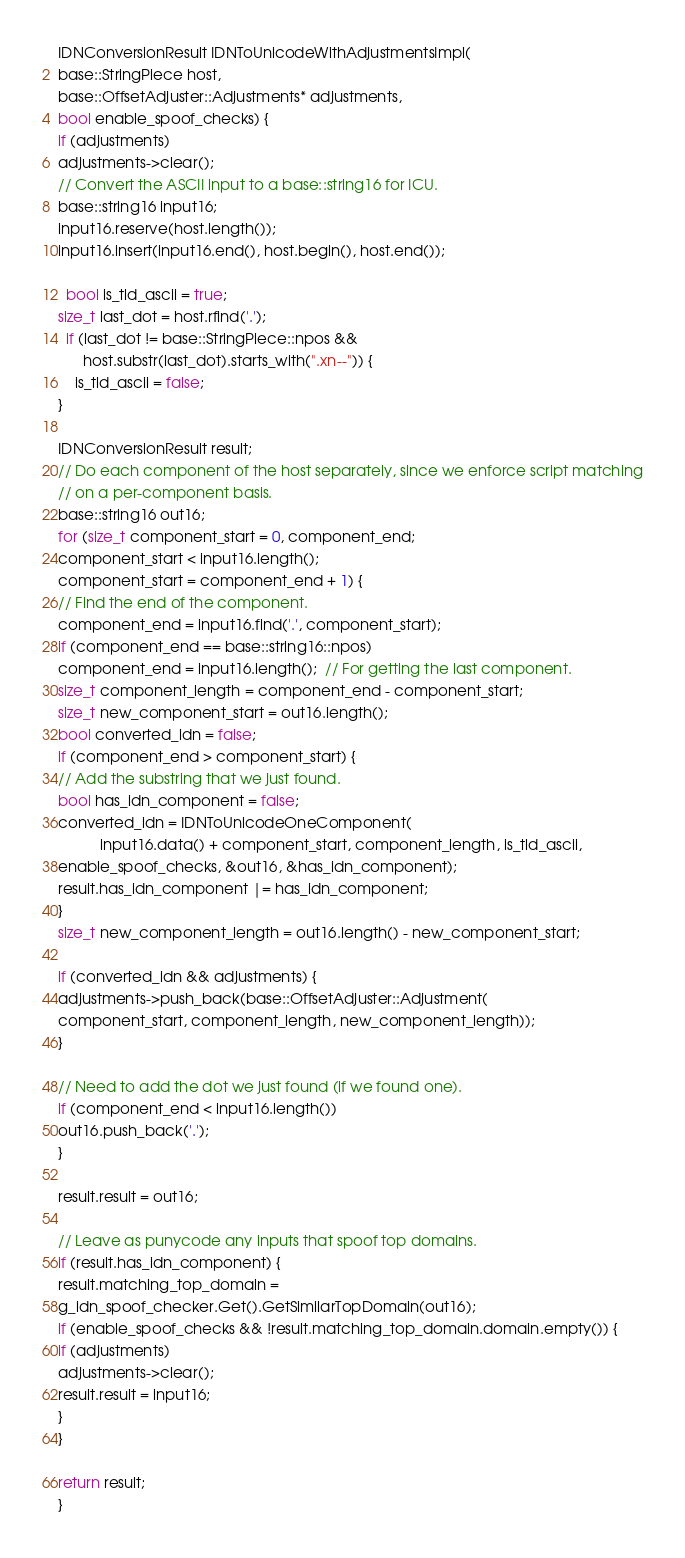<code> <loc_0><loc_0><loc_500><loc_500><_C++_>IDNConversionResult IDNToUnicodeWithAdjustmentsImpl(
base::StringPiece host,
base::OffsetAdjuster::Adjustments* adjustments,
bool enable_spoof_checks) {
if (adjustments)
adjustments->clear();
// Convert the ASCII input to a base::string16 for ICU.
base::string16 input16;
input16.reserve(host.length());
input16.insert(input16.end(), host.begin(), host.end());

  bool is_tld_ascii = true;
size_t last_dot = host.rfind('.');
  if (last_dot != base::StringPiece::npos &&
      host.substr(last_dot).starts_with(".xn--")) {
    is_tld_ascii = false;
}

IDNConversionResult result;
// Do each component of the host separately, since we enforce script matching
// on a per-component basis.
base::string16 out16;
for (size_t component_start = 0, component_end;
component_start < input16.length();
component_start = component_end + 1) {
// Find the end of the component.
component_end = input16.find('.', component_start);
if (component_end == base::string16::npos)
component_end = input16.length();  // For getting the last component.
size_t component_length = component_end - component_start;
size_t new_component_start = out16.length();
bool converted_idn = false;
if (component_end > component_start) {
// Add the substring that we just found.
bool has_idn_component = false;
converted_idn = IDNToUnicodeOneComponent(
          input16.data() + component_start, component_length, is_tld_ascii,
enable_spoof_checks, &out16, &has_idn_component);
result.has_idn_component |= has_idn_component;
}
size_t new_component_length = out16.length() - new_component_start;

if (converted_idn && adjustments) {
adjustments->push_back(base::OffsetAdjuster::Adjustment(
component_start, component_length, new_component_length));
}

// Need to add the dot we just found (if we found one).
if (component_end < input16.length())
out16.push_back('.');
}

result.result = out16;

// Leave as punycode any inputs that spoof top domains.
if (result.has_idn_component) {
result.matching_top_domain =
g_idn_spoof_checker.Get().GetSimilarTopDomain(out16);
if (enable_spoof_checks && !result.matching_top_domain.domain.empty()) {
if (adjustments)
adjustments->clear();
result.result = input16;
}
}

return result;
}
</code> 